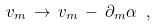Convert formula to latex. <formula><loc_0><loc_0><loc_500><loc_500>v _ { m } \, \rightarrow \, v _ { m } \, - \, \partial _ { m } \alpha \ ,</formula> 